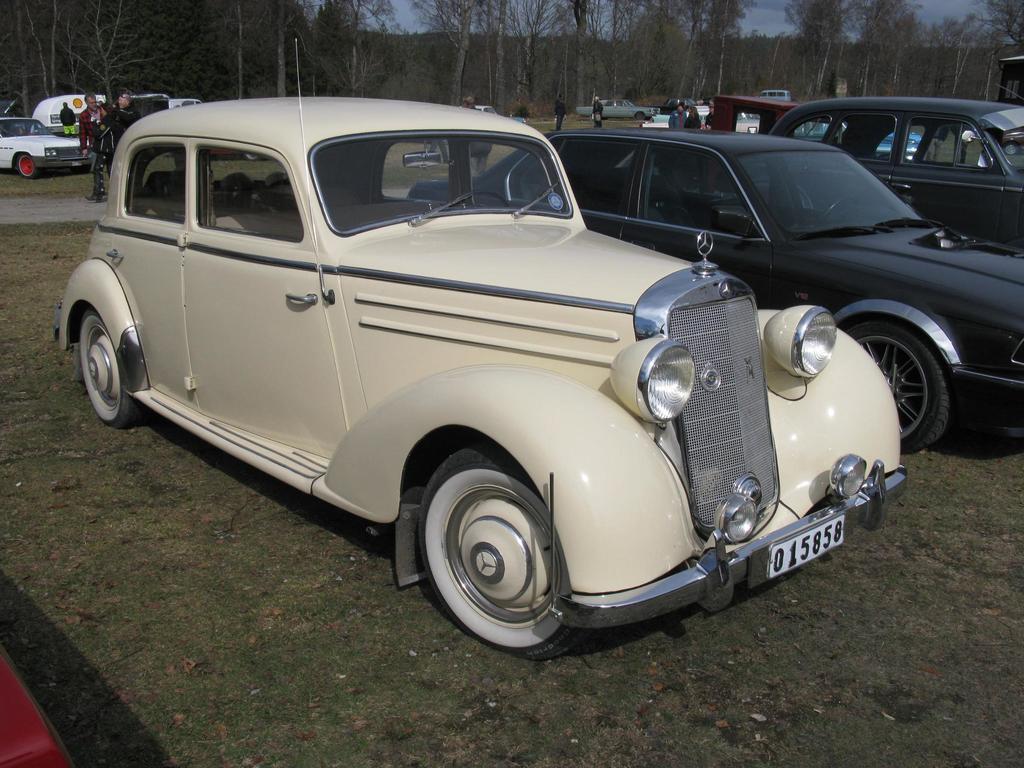Could you give a brief overview of what you see in this image? In the foreground of the picture we can see cars and road. In the middle of the picture we can see people, vehicles and road. In the background there are trees and sky. 